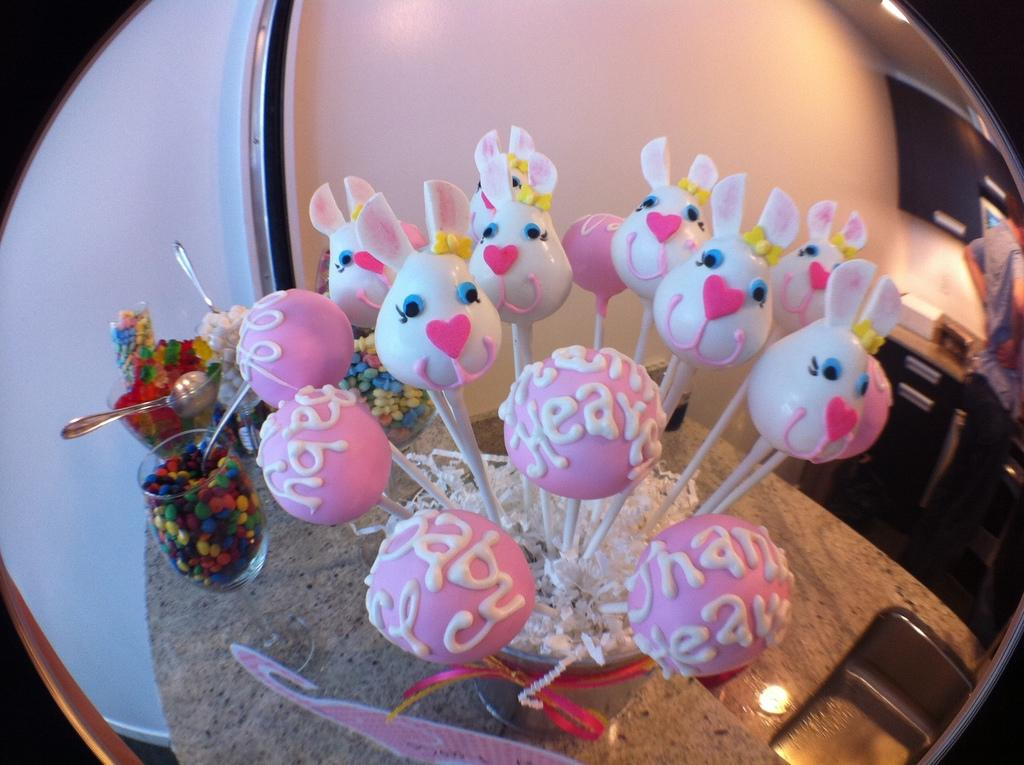What type of food is present in the image? There are candies in the image. What historical event is depicted in the image? There is no historical event depicted in the image; it only contains candies. What error is present in the image? There is no error present in the image; it accurately shows candies. 